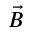<formula> <loc_0><loc_0><loc_500><loc_500>\vec { B }</formula> 